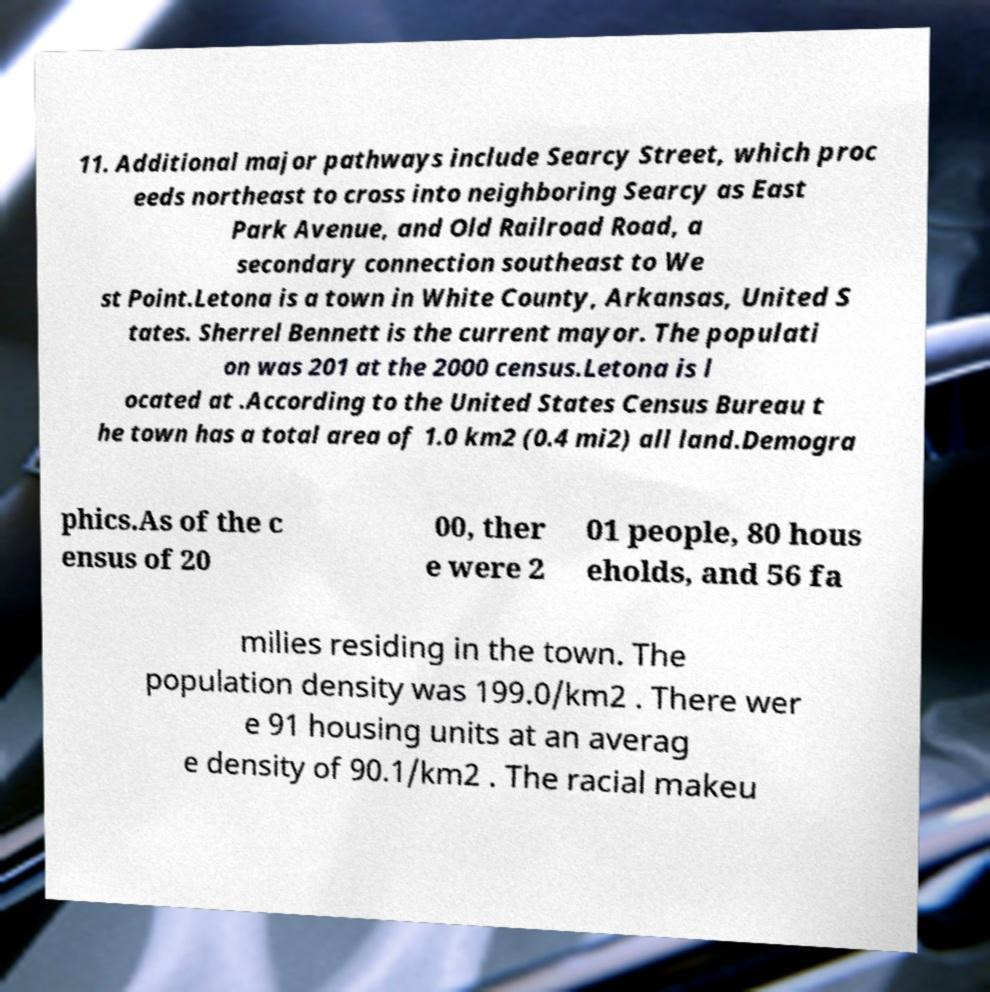There's text embedded in this image that I need extracted. Can you transcribe it verbatim? 11. Additional major pathways include Searcy Street, which proc eeds northeast to cross into neighboring Searcy as East Park Avenue, and Old Railroad Road, a secondary connection southeast to We st Point.Letona is a town in White County, Arkansas, United S tates. Sherrel Bennett is the current mayor. The populati on was 201 at the 2000 census.Letona is l ocated at .According to the United States Census Bureau t he town has a total area of 1.0 km2 (0.4 mi2) all land.Demogra phics.As of the c ensus of 20 00, ther e were 2 01 people, 80 hous eholds, and 56 fa milies residing in the town. The population density was 199.0/km2 . There wer e 91 housing units at an averag e density of 90.1/km2 . The racial makeu 